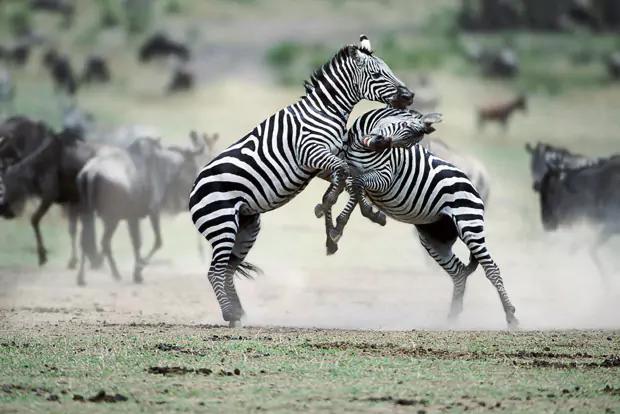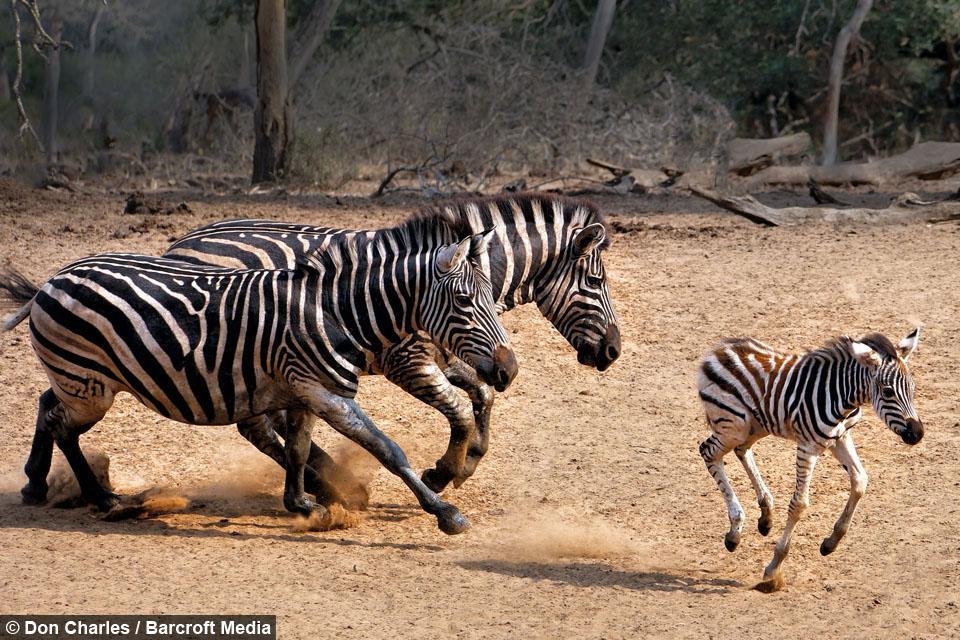The first image is the image on the left, the second image is the image on the right. For the images displayed, is the sentence "The right image contains exactly two zebras." factually correct? Answer yes or no. No. The first image is the image on the left, the second image is the image on the right. Examine the images to the left and right. Is the description "Two zebras play with each other in a field in each of the images." accurate? Answer yes or no. No. 